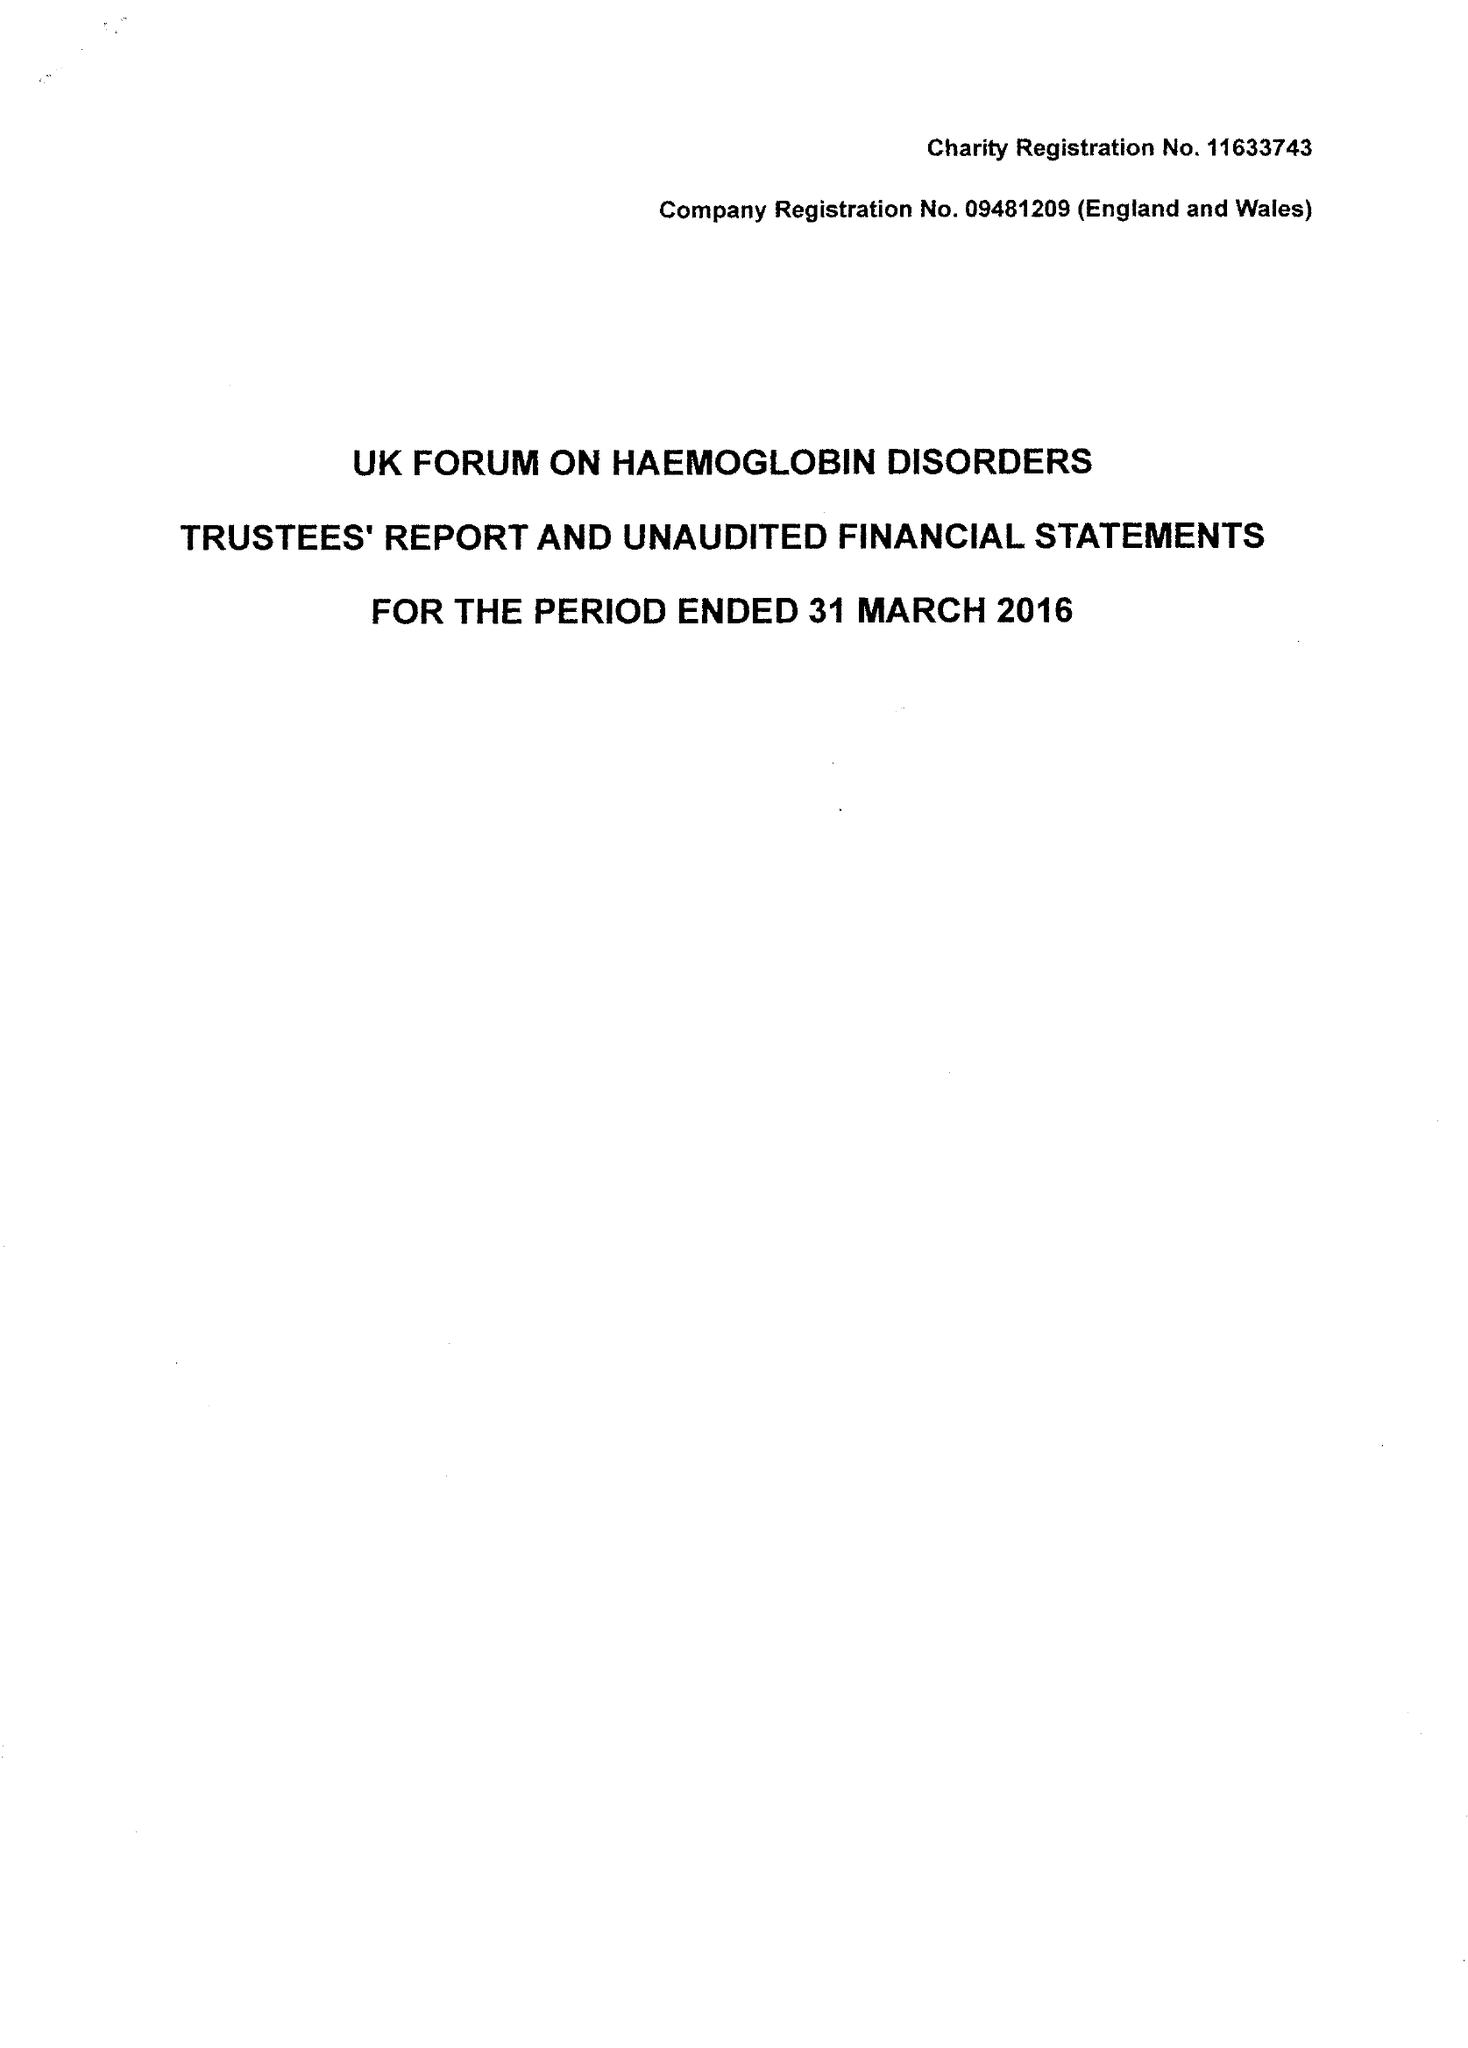What is the value for the address__postcode?
Answer the question using a single word or phrase. SE1 9RT 